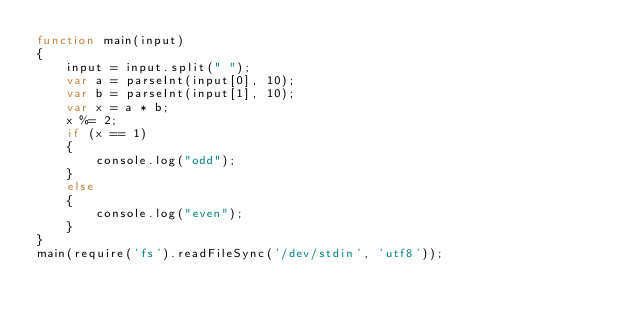Convert code to text. <code><loc_0><loc_0><loc_500><loc_500><_JavaScript_>function main(input) 
{
    input = input.split(" ");
    var a = parseInt(input[0], 10);
    var b = parseInt(input[1], 10);
    var x = a * b;
    x %= 2;
    if (x == 1)
    {
        console.log("odd");
    }
    else
    {
        console.log("even");
    }
}
main(require('fs').readFileSync('/dev/stdin', 'utf8'));</code> 